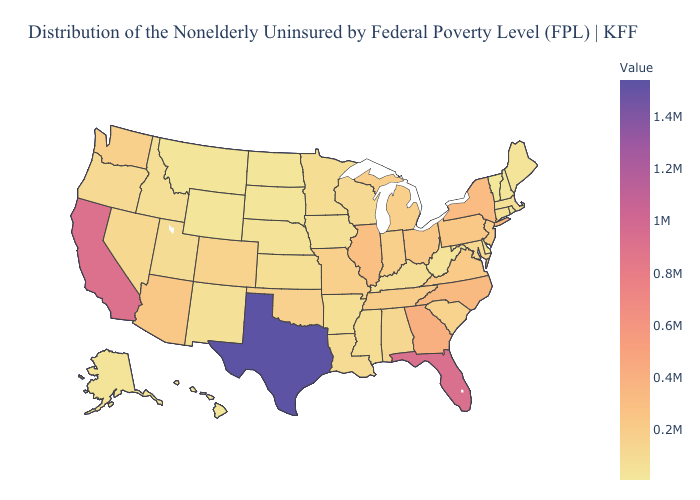Does Wisconsin have the lowest value in the USA?
Write a very short answer. No. Does Tennessee have the lowest value in the USA?
Keep it brief. No. Among the states that border Missouri , does Oklahoma have the highest value?
Quick response, please. No. 